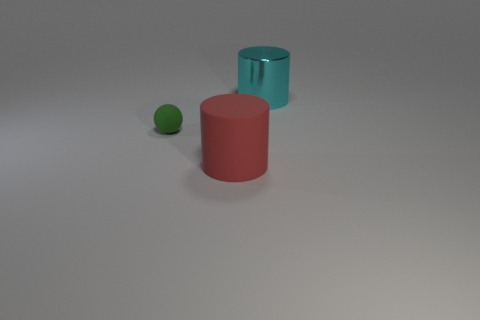Is there any other thing that has the same material as the cyan cylinder?
Make the answer very short. No. Is there anything else that has the same size as the green object?
Keep it short and to the point. No. Is there anything else that has the same shape as the small object?
Provide a succinct answer. No. Is the sphere the same size as the red matte cylinder?
Offer a terse response. No. How many other objects are the same size as the green matte thing?
Give a very brief answer. 0. How many objects are things on the right side of the small green ball or things in front of the cyan cylinder?
Keep it short and to the point. 3. What shape is the rubber thing that is the same size as the metal thing?
Your response must be concise. Cylinder. What is the size of the sphere that is made of the same material as the big red object?
Make the answer very short. Small. Is the shape of the shiny thing the same as the small green rubber object?
Your answer should be compact. No. There is a thing that is the same size as the cyan shiny cylinder; what is its color?
Provide a succinct answer. Red. 